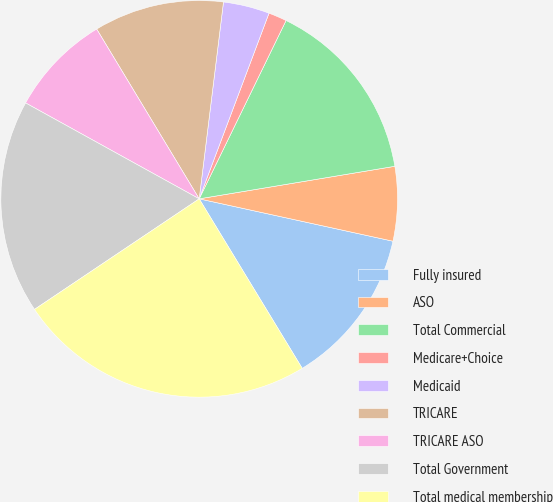Convert chart. <chart><loc_0><loc_0><loc_500><loc_500><pie_chart><fcel>Fully insured<fcel>ASO<fcel>Total Commercial<fcel>Medicare+Choice<fcel>Medicaid<fcel>TRICARE<fcel>TRICARE ASO<fcel>Total Government<fcel>Total medical membership<nl><fcel>12.88%<fcel>6.05%<fcel>15.16%<fcel>1.49%<fcel>3.77%<fcel>10.6%<fcel>8.32%<fcel>17.44%<fcel>24.28%<nl></chart> 